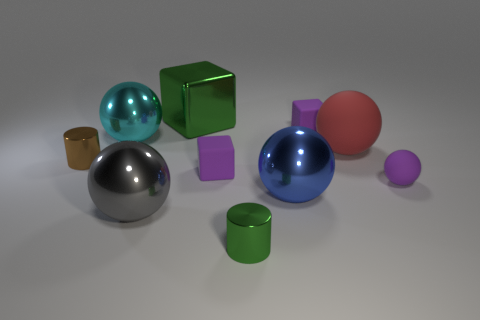There is a gray ball that is in front of the rubber cube that is right of the tiny purple block that is on the left side of the big blue shiny object; what is its size? The gray ball situated in front of the rubber cube, and itself positioned right of the tiny purple block on the left of the large blue shiny sphere, appears to be medium-sized in comparison to the objects surrounding it. 